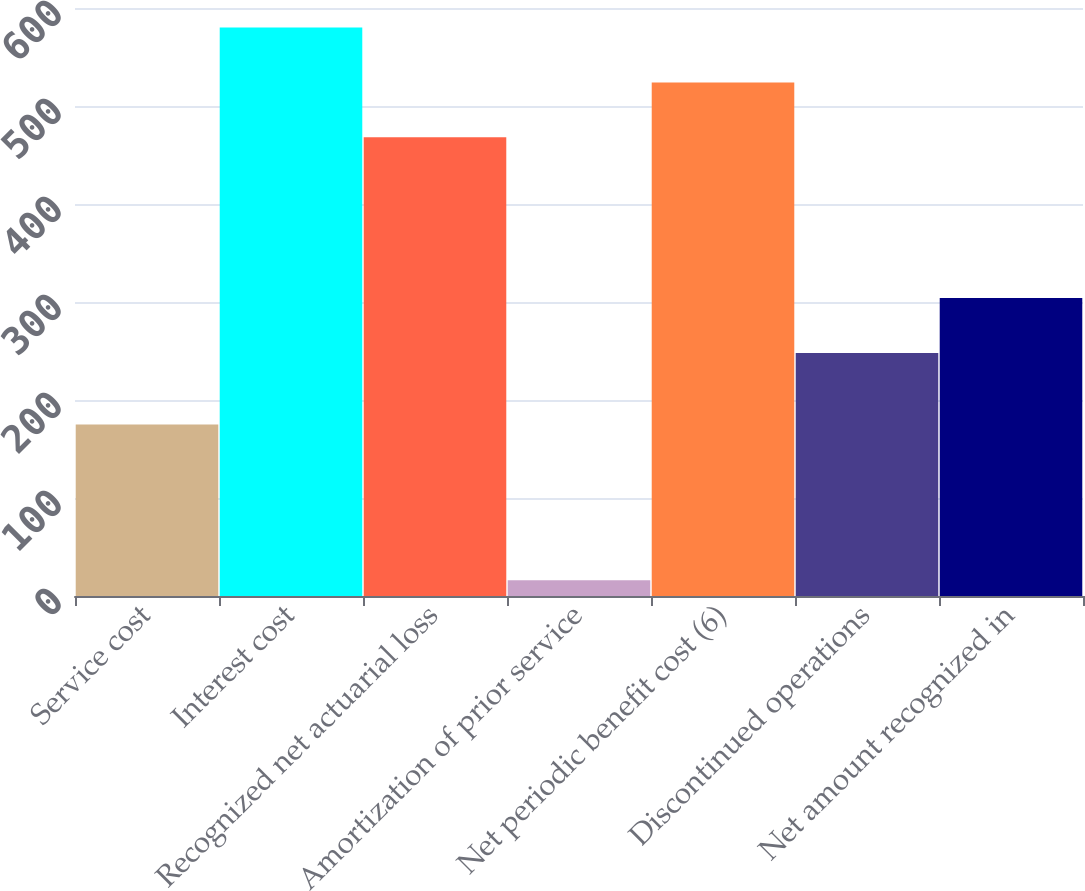<chart> <loc_0><loc_0><loc_500><loc_500><bar_chart><fcel>Service cost<fcel>Interest cost<fcel>Recognized net actuarial loss<fcel>Amortization of prior service<fcel>Net periodic benefit cost (6)<fcel>Discontinued operations<fcel>Net amount recognized in<nl><fcel>175<fcel>580.2<fcel>468<fcel>16<fcel>524.1<fcel>248<fcel>304.1<nl></chart> 